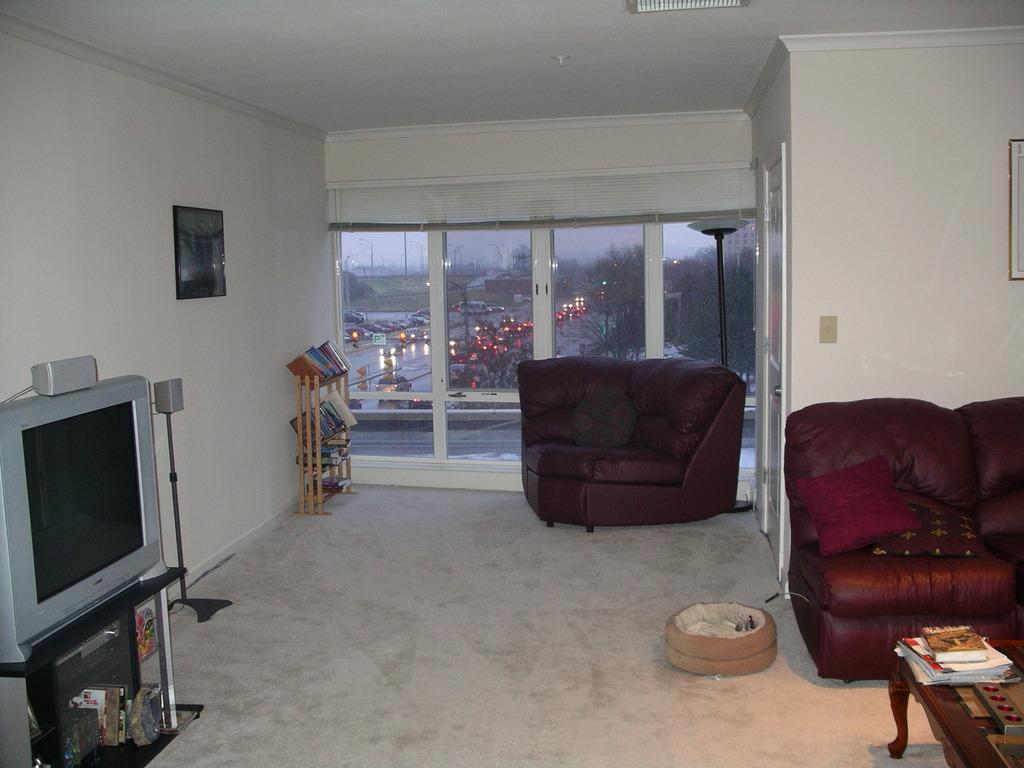In one or two sentences, can you explain what this image depicts? It´s a closed room where on the right corner of the picture there is one sofa with pillows on it and in the left corner of the picture there is a tv on the stand behind it there is a wall with a photo on it and on the corner of the picture there is a books rack and opposite to that there is a small sofa with a pillow, behind that there are glass doors and outside of the room there are cars on the roads and number of trees are there, coming to the right corner of the picture there is table and books on it and in the middle of the room there is a small cat bed is there. 